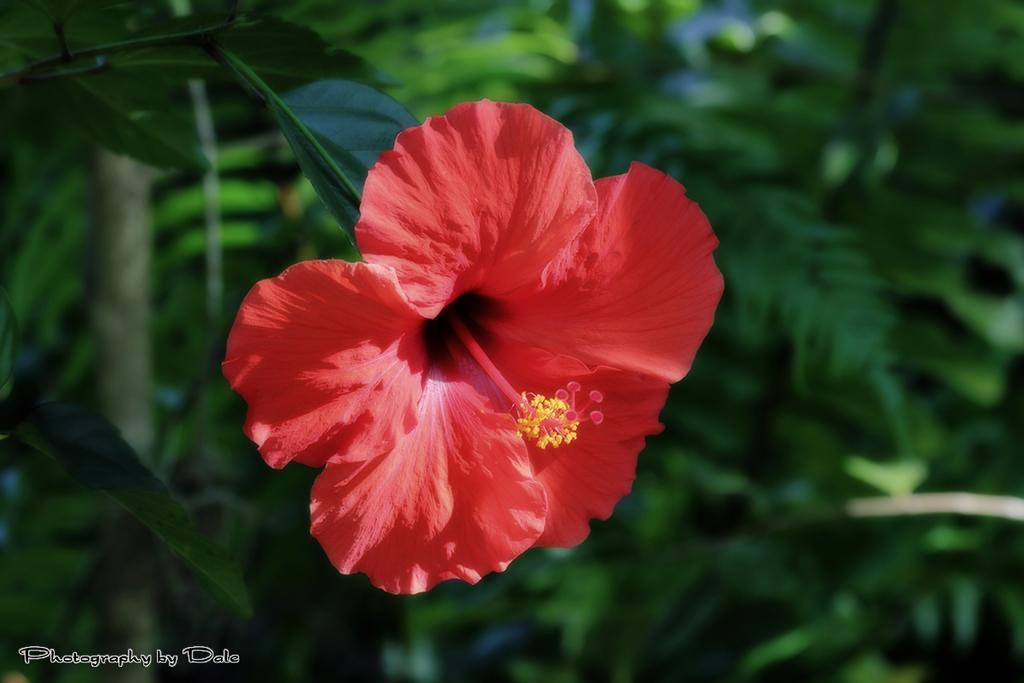What is the main subject in the foreground of the image? There is a flower in the foreground of the image. What color is the flower? The flower is red. How would you describe the background of the image? The background of the image is blurred. What type of wool is being used to create the actor's costume in the image? There is no actor or costume present in the image; it features a red flower in the foreground and a blurred background. 